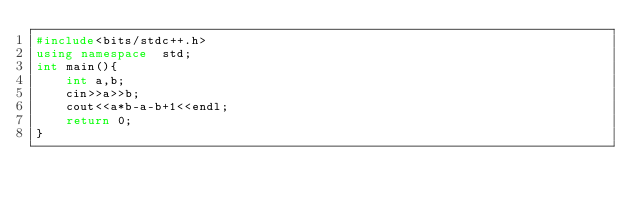Convert code to text. <code><loc_0><loc_0><loc_500><loc_500><_C++_>#include<bits/stdc++.h>
using namespace  std;
int main(){
    int a,b;
    cin>>a>>b;
    cout<<a*b-a-b+1<<endl;
    return 0;
}
</code> 